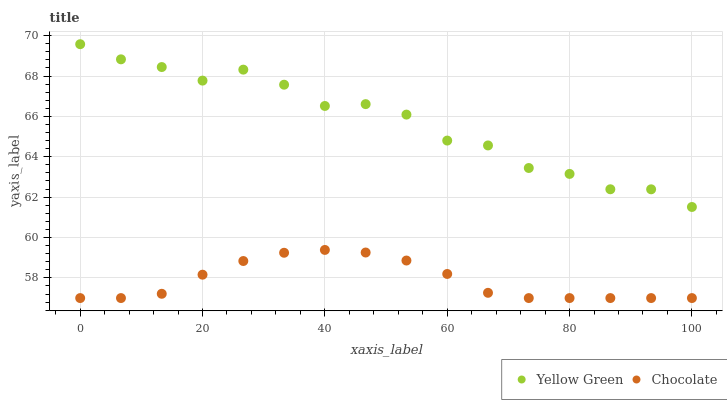Does Chocolate have the minimum area under the curve?
Answer yes or no. Yes. Does Yellow Green have the maximum area under the curve?
Answer yes or no. Yes. Does Chocolate have the maximum area under the curve?
Answer yes or no. No. Is Chocolate the smoothest?
Answer yes or no. Yes. Is Yellow Green the roughest?
Answer yes or no. Yes. Is Chocolate the roughest?
Answer yes or no. No. Does Chocolate have the lowest value?
Answer yes or no. Yes. Does Yellow Green have the highest value?
Answer yes or no. Yes. Does Chocolate have the highest value?
Answer yes or no. No. Is Chocolate less than Yellow Green?
Answer yes or no. Yes. Is Yellow Green greater than Chocolate?
Answer yes or no. Yes. Does Chocolate intersect Yellow Green?
Answer yes or no. No. 